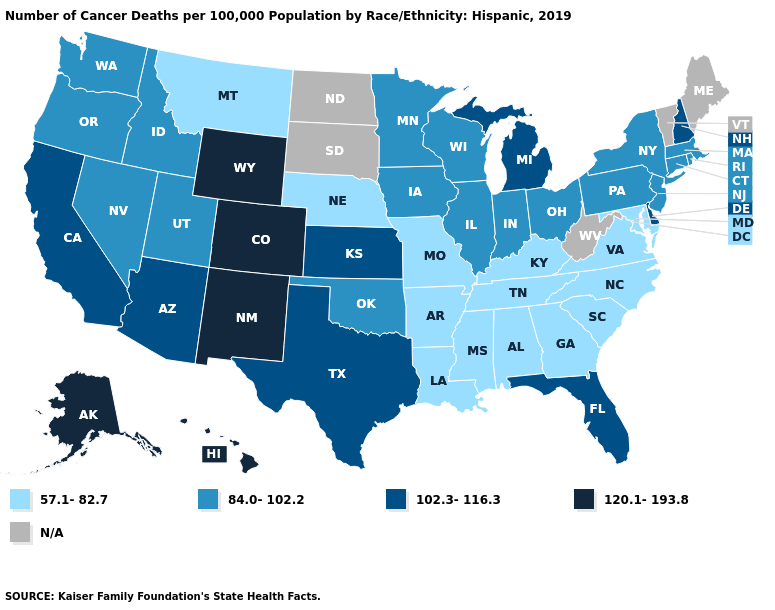Name the states that have a value in the range 120.1-193.8?
Be succinct. Alaska, Colorado, Hawaii, New Mexico, Wyoming. Name the states that have a value in the range 120.1-193.8?
Give a very brief answer. Alaska, Colorado, Hawaii, New Mexico, Wyoming. Does Nevada have the lowest value in the USA?
Concise answer only. No. What is the value of Georgia?
Concise answer only. 57.1-82.7. What is the value of Delaware?
Be succinct. 102.3-116.3. What is the lowest value in states that border Minnesota?
Be succinct. 84.0-102.2. Name the states that have a value in the range 102.3-116.3?
Keep it brief. Arizona, California, Delaware, Florida, Kansas, Michigan, New Hampshire, Texas. How many symbols are there in the legend?
Keep it brief. 5. Among the states that border Indiana , does Illinois have the lowest value?
Short answer required. No. Does Iowa have the lowest value in the USA?
Write a very short answer. No. What is the value of Kansas?
Answer briefly. 102.3-116.3. Which states have the lowest value in the West?
Be succinct. Montana. Among the states that border Indiana , which have the highest value?
Short answer required. Michigan. 